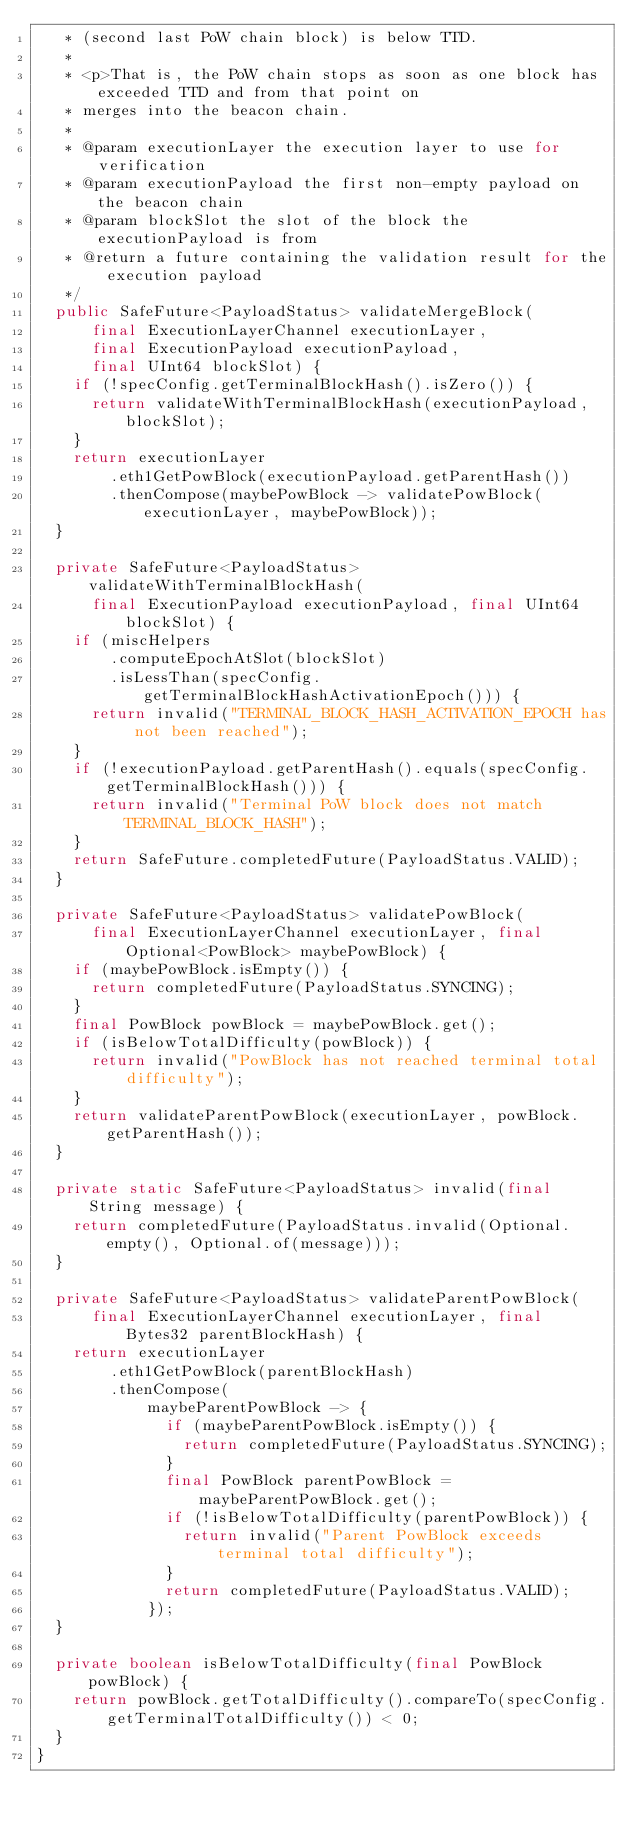Convert code to text. <code><loc_0><loc_0><loc_500><loc_500><_Java_>   * (second last PoW chain block) is below TTD.
   *
   * <p>That is, the PoW chain stops as soon as one block has exceeded TTD and from that point on
   * merges into the beacon chain.
   *
   * @param executionLayer the execution layer to use for verification
   * @param executionPayload the first non-empty payload on the beacon chain
   * @param blockSlot the slot of the block the executionPayload is from
   * @return a future containing the validation result for the execution payload
   */
  public SafeFuture<PayloadStatus> validateMergeBlock(
      final ExecutionLayerChannel executionLayer,
      final ExecutionPayload executionPayload,
      final UInt64 blockSlot) {
    if (!specConfig.getTerminalBlockHash().isZero()) {
      return validateWithTerminalBlockHash(executionPayload, blockSlot);
    }
    return executionLayer
        .eth1GetPowBlock(executionPayload.getParentHash())
        .thenCompose(maybePowBlock -> validatePowBlock(executionLayer, maybePowBlock));
  }

  private SafeFuture<PayloadStatus> validateWithTerminalBlockHash(
      final ExecutionPayload executionPayload, final UInt64 blockSlot) {
    if (miscHelpers
        .computeEpochAtSlot(blockSlot)
        .isLessThan(specConfig.getTerminalBlockHashActivationEpoch())) {
      return invalid("TERMINAL_BLOCK_HASH_ACTIVATION_EPOCH has not been reached");
    }
    if (!executionPayload.getParentHash().equals(specConfig.getTerminalBlockHash())) {
      return invalid("Terminal PoW block does not match TERMINAL_BLOCK_HASH");
    }
    return SafeFuture.completedFuture(PayloadStatus.VALID);
  }

  private SafeFuture<PayloadStatus> validatePowBlock(
      final ExecutionLayerChannel executionLayer, final Optional<PowBlock> maybePowBlock) {
    if (maybePowBlock.isEmpty()) {
      return completedFuture(PayloadStatus.SYNCING);
    }
    final PowBlock powBlock = maybePowBlock.get();
    if (isBelowTotalDifficulty(powBlock)) {
      return invalid("PowBlock has not reached terminal total difficulty");
    }
    return validateParentPowBlock(executionLayer, powBlock.getParentHash());
  }

  private static SafeFuture<PayloadStatus> invalid(final String message) {
    return completedFuture(PayloadStatus.invalid(Optional.empty(), Optional.of(message)));
  }

  private SafeFuture<PayloadStatus> validateParentPowBlock(
      final ExecutionLayerChannel executionLayer, final Bytes32 parentBlockHash) {
    return executionLayer
        .eth1GetPowBlock(parentBlockHash)
        .thenCompose(
            maybeParentPowBlock -> {
              if (maybeParentPowBlock.isEmpty()) {
                return completedFuture(PayloadStatus.SYNCING);
              }
              final PowBlock parentPowBlock = maybeParentPowBlock.get();
              if (!isBelowTotalDifficulty(parentPowBlock)) {
                return invalid("Parent PowBlock exceeds terminal total difficulty");
              }
              return completedFuture(PayloadStatus.VALID);
            });
  }

  private boolean isBelowTotalDifficulty(final PowBlock powBlock) {
    return powBlock.getTotalDifficulty().compareTo(specConfig.getTerminalTotalDifficulty()) < 0;
  }
}
</code> 